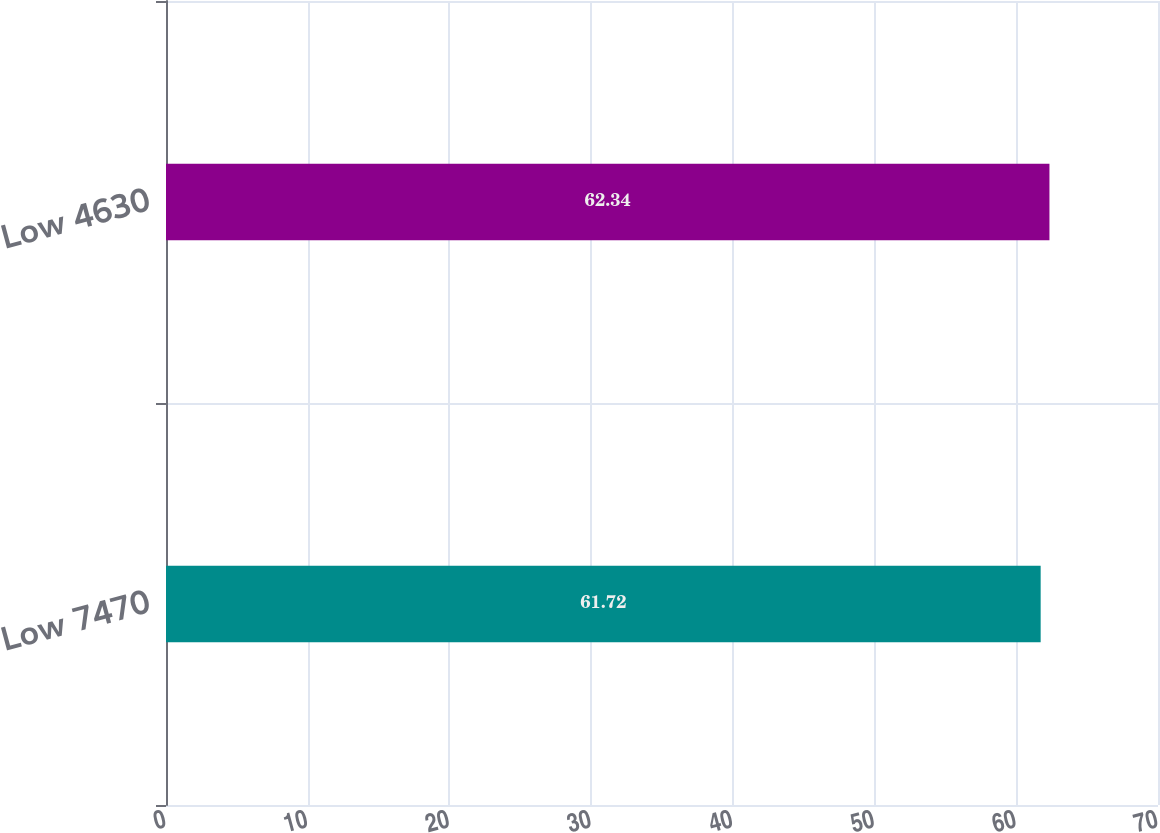Convert chart to OTSL. <chart><loc_0><loc_0><loc_500><loc_500><bar_chart><fcel>Low 7470<fcel>Low 4630<nl><fcel>61.72<fcel>62.34<nl></chart> 